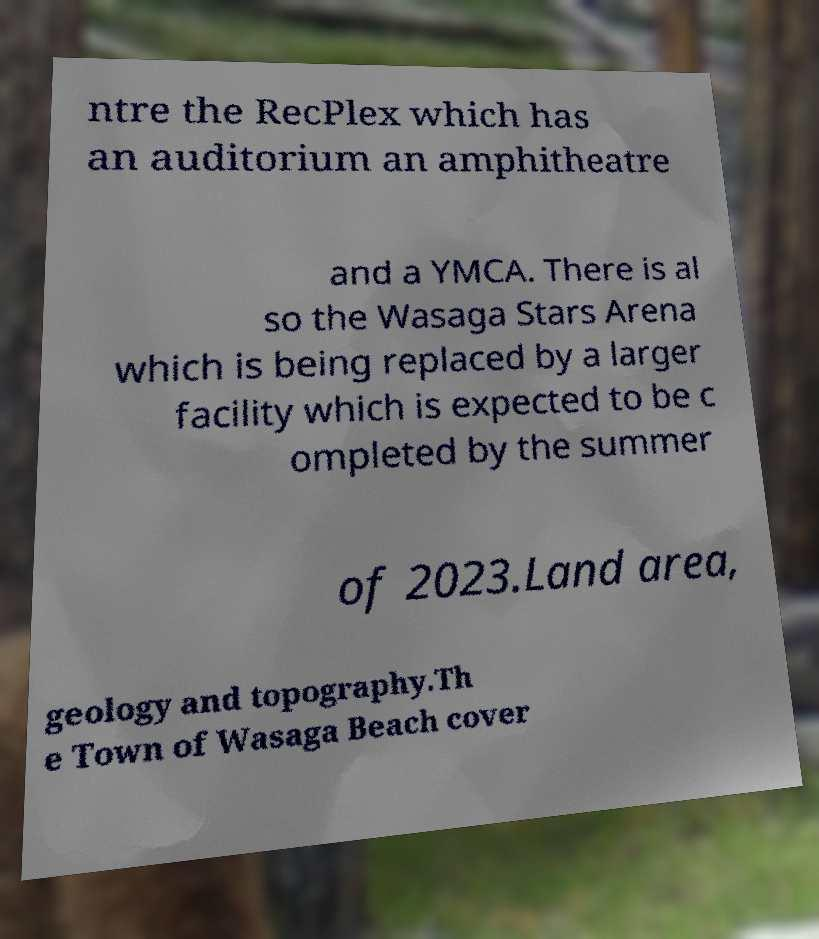What messages or text are displayed in this image? I need them in a readable, typed format. ntre the RecPlex which has an auditorium an amphitheatre and a YMCA. There is al so the Wasaga Stars Arena which is being replaced by a larger facility which is expected to be c ompleted by the summer of 2023.Land area, geology and topography.Th e Town of Wasaga Beach cover 